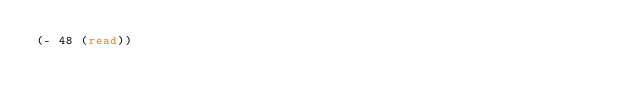Convert code to text. <code><loc_0><loc_0><loc_500><loc_500><_Lisp_>(- 48 (read))</code> 